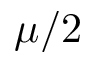Convert formula to latex. <formula><loc_0><loc_0><loc_500><loc_500>\mu / 2</formula> 